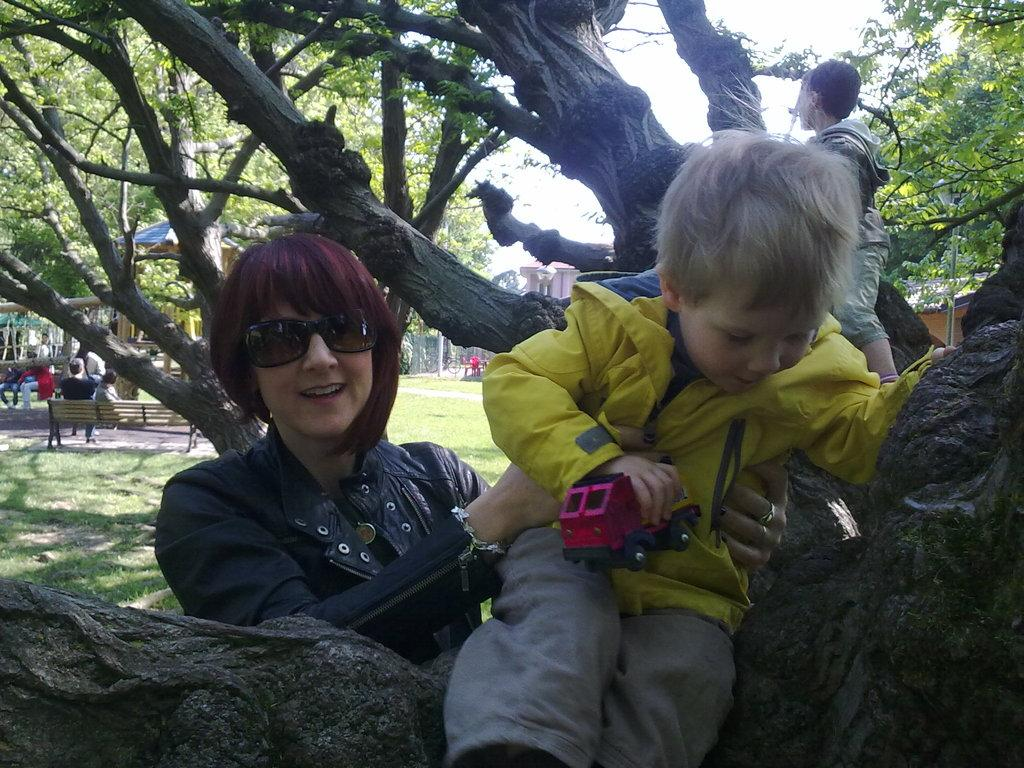What is the boy doing in the image? The boy is sitting on a branch in the image. Who else is present in the image besides the boy? There are people in the image. What can be seen on the left side of the image? There is a bench on the left side of the image. What is visible in the background of the image? There are trees and the sky in the background of the image. What type of spark can be seen coming from the queen's hand in the image? There is no queen or spark present in the image. What government policy is being discussed by the people in the image? The image does not depict any discussion about government policies. 